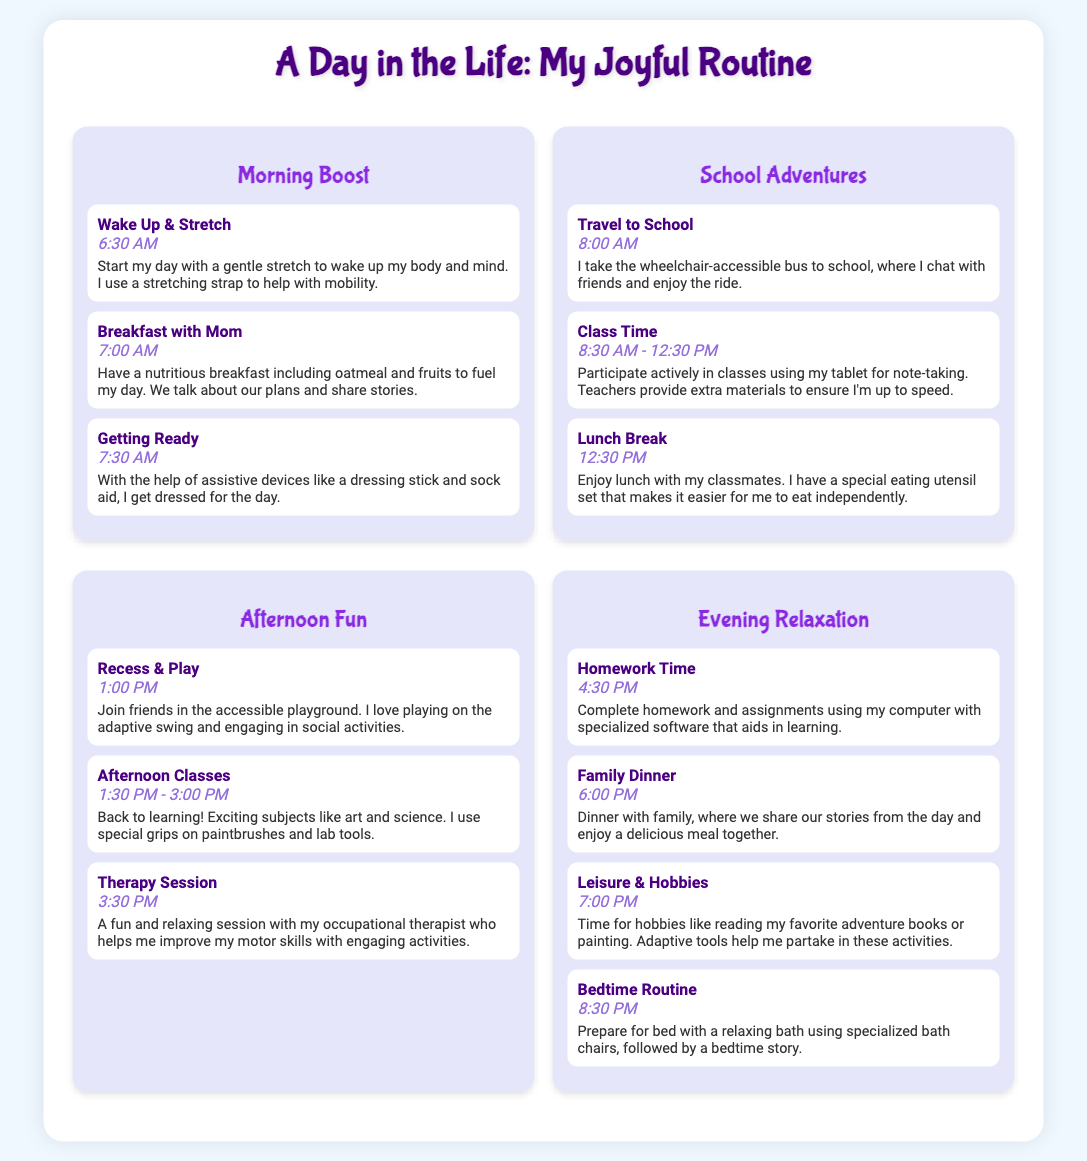what time do I wake up? The time I wake up is mentioned under the "Morning Boost" section in the document.
Answer: 6:30 AM what do I use to help with mobility while stretching? The document states that I use a stretching strap to assist during stretching.
Answer: stretching strap how long is my class time at school? The class duration is specified in the "Class Time" activity, which outlines a time span.
Answer: 4 hours what is the first activity of the evening? The first activity listed in the evening section is about completing homework.
Answer: Homework Time what type of bus do I take to school? The document explains that I take a wheelchair-accessible bus to get to school.
Answer: wheelchair-accessible bus how do I enjoy my lunch at school? The description under "Lunch Break" mentions how I have a special eating utensil set to help me eat independently.
Answer: special eating utensil set what therapy session do I have in the afternoon? The afternoon activity mentions having a session with my occupational therapist for skill improvement.
Answer: Therapy Session what tools do I use for painting? The document states that I use special grips on paintbrushes to aid in painting.
Answer: special grips what do we do during family dinner? The description mentions that we share stories and enjoy a meal together during dinner time.
Answer: share stories 